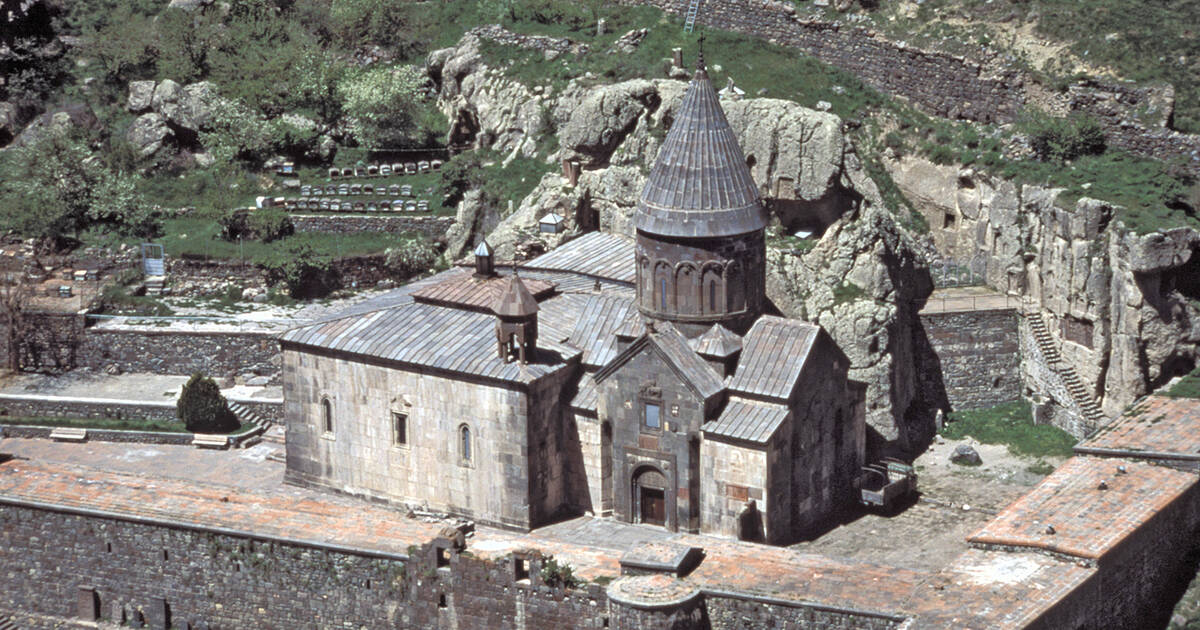Can you elaborate on the elements of the picture provided? The image depicts the historically significant Geghard Monastery in Armenia, expertly carved into the rugged cliff faces of the Azat Valley. This architectural masterpiece boasts a complex of medieval buildings, primarily constructed from the indigenous basalt rock, which blends naturally with the surrounding landscape. The central cathedral with its conical dome showcases traditional Armenian religious architecture, while the intricate khachkars (cross-stones) and medieval carvings that adorn its facades speak volumes of the artisan skill and spiritual devotion of its builders.

The verdant surroundings and the skillfully engineered structures, including terraced walls and stairs, accentuate the monastery’s strategic and spiritual isolation. Despite the tough terrain, the builders achieved a harmonious balance between nature and architecture, creating a serene yet commanding presence, profound not only in its religious significance but also as a symbol of Armenian resilience and artistic heritage. This broader context emphasizes the monastery's deep historical and cultural importance to Armenia. 